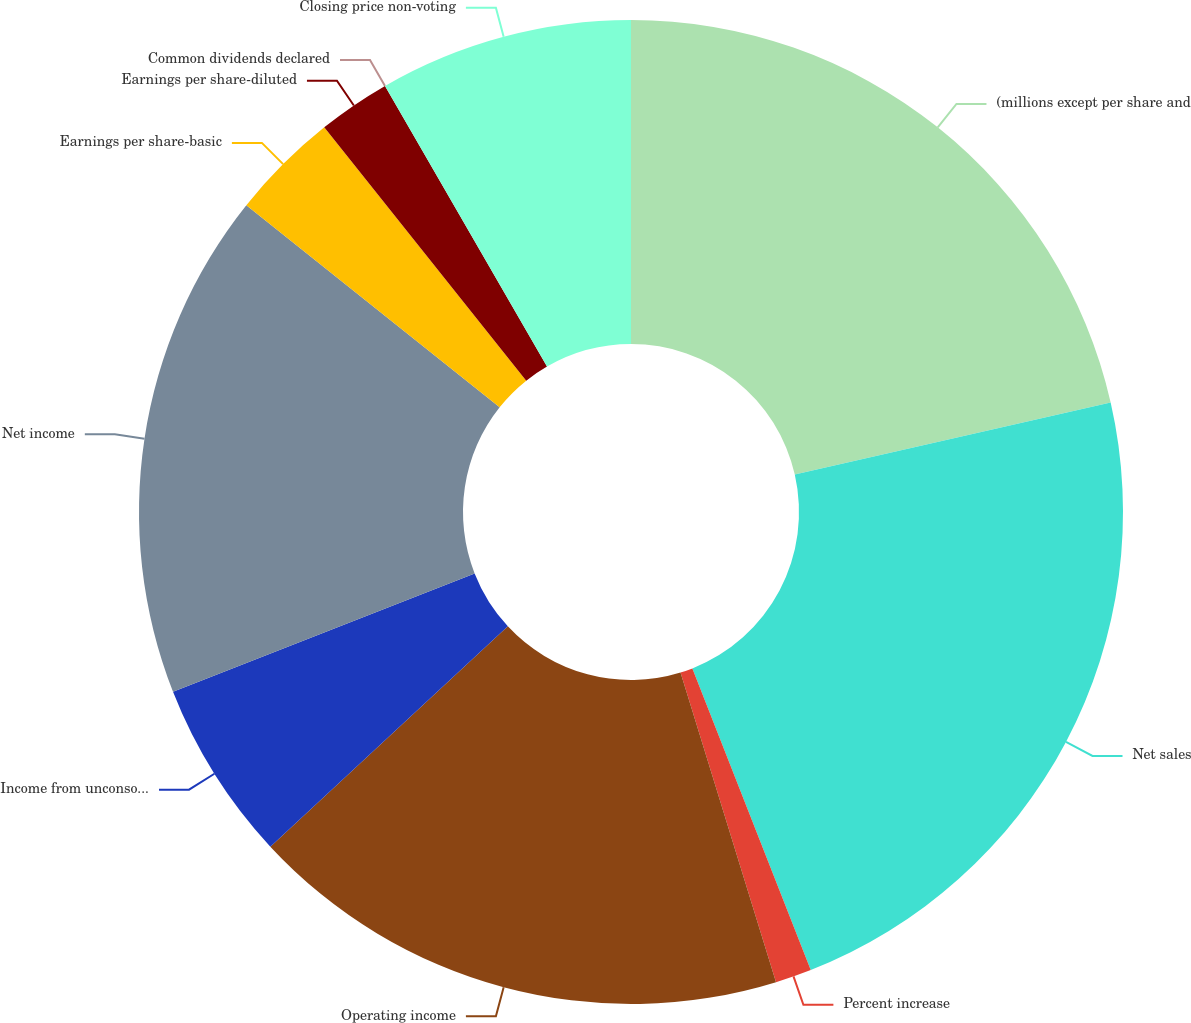Convert chart to OTSL. <chart><loc_0><loc_0><loc_500><loc_500><pie_chart><fcel>(millions except per share and<fcel>Net sales<fcel>Percent increase<fcel>Operating income<fcel>Income from unconsolidated<fcel>Net income<fcel>Earnings per share-basic<fcel>Earnings per share-diluted<fcel>Common dividends declared<fcel>Closing price non-voting<nl><fcel>21.42%<fcel>22.61%<fcel>1.19%<fcel>17.85%<fcel>5.95%<fcel>16.66%<fcel>3.57%<fcel>2.38%<fcel>0.0%<fcel>8.33%<nl></chart> 